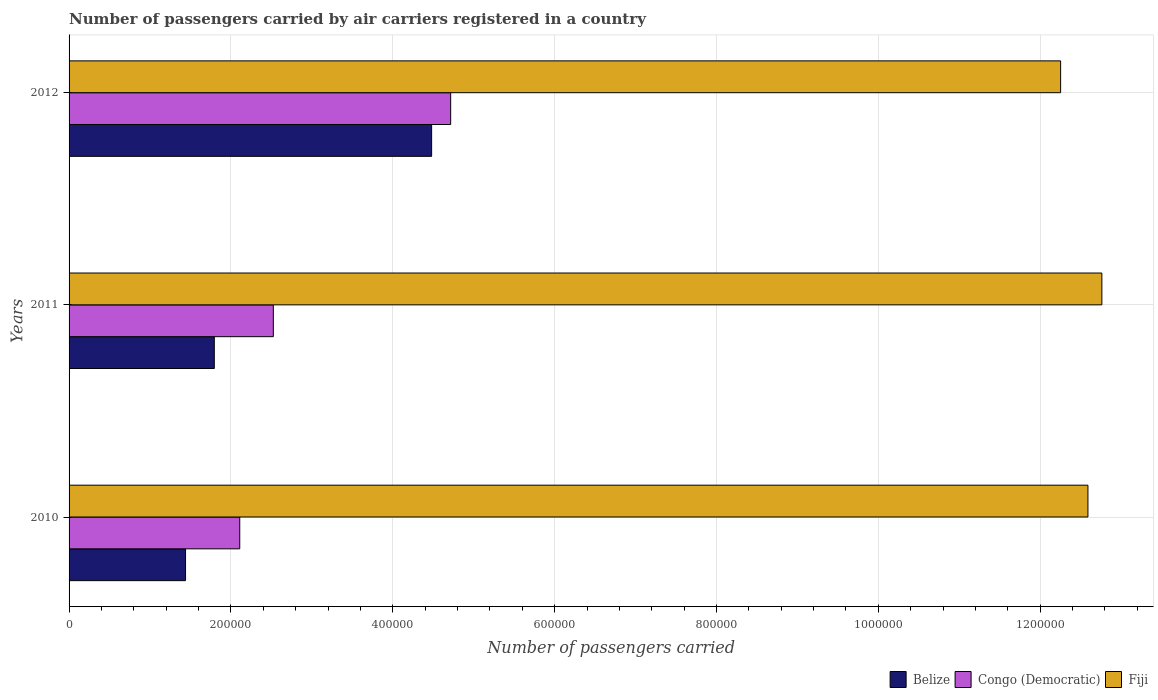How many different coloured bars are there?
Ensure brevity in your answer.  3. How many bars are there on the 3rd tick from the bottom?
Your answer should be very brief. 3. What is the label of the 3rd group of bars from the top?
Provide a short and direct response. 2010. In how many cases, is the number of bars for a given year not equal to the number of legend labels?
Your response must be concise. 0. What is the number of passengers carried by air carriers in Belize in 2011?
Make the answer very short. 1.79e+05. Across all years, what is the maximum number of passengers carried by air carriers in Congo (Democratic)?
Make the answer very short. 4.72e+05. Across all years, what is the minimum number of passengers carried by air carriers in Belize?
Provide a short and direct response. 1.44e+05. What is the total number of passengers carried by air carriers in Congo (Democratic) in the graph?
Provide a short and direct response. 9.35e+05. What is the difference between the number of passengers carried by air carriers in Belize in 2011 and that in 2012?
Your answer should be very brief. -2.69e+05. What is the difference between the number of passengers carried by air carriers in Belize in 2010 and the number of passengers carried by air carriers in Fiji in 2012?
Make the answer very short. -1.08e+06. What is the average number of passengers carried by air carriers in Belize per year?
Your answer should be compact. 2.57e+05. In the year 2010, what is the difference between the number of passengers carried by air carriers in Fiji and number of passengers carried by air carriers in Congo (Democratic)?
Ensure brevity in your answer.  1.05e+06. In how many years, is the number of passengers carried by air carriers in Congo (Democratic) greater than 720000 ?
Ensure brevity in your answer.  0. What is the ratio of the number of passengers carried by air carriers in Fiji in 2010 to that in 2012?
Make the answer very short. 1.03. Is the number of passengers carried by air carriers in Fiji in 2011 less than that in 2012?
Your response must be concise. No. What is the difference between the highest and the second highest number of passengers carried by air carriers in Congo (Democratic)?
Your answer should be very brief. 2.19e+05. What is the difference between the highest and the lowest number of passengers carried by air carriers in Congo (Democratic)?
Your answer should be very brief. 2.61e+05. In how many years, is the number of passengers carried by air carriers in Belize greater than the average number of passengers carried by air carriers in Belize taken over all years?
Your response must be concise. 1. Is the sum of the number of passengers carried by air carriers in Congo (Democratic) in 2011 and 2012 greater than the maximum number of passengers carried by air carriers in Fiji across all years?
Your response must be concise. No. What does the 2nd bar from the top in 2011 represents?
Your response must be concise. Congo (Democratic). What does the 2nd bar from the bottom in 2011 represents?
Keep it short and to the point. Congo (Democratic). Is it the case that in every year, the sum of the number of passengers carried by air carriers in Belize and number of passengers carried by air carriers in Congo (Democratic) is greater than the number of passengers carried by air carriers in Fiji?
Your response must be concise. No. How many years are there in the graph?
Offer a very short reply. 3. Are the values on the major ticks of X-axis written in scientific E-notation?
Your answer should be very brief. No. Does the graph contain grids?
Keep it short and to the point. Yes. How many legend labels are there?
Your response must be concise. 3. How are the legend labels stacked?
Ensure brevity in your answer.  Horizontal. What is the title of the graph?
Offer a terse response. Number of passengers carried by air carriers registered in a country. Does "Spain" appear as one of the legend labels in the graph?
Ensure brevity in your answer.  No. What is the label or title of the X-axis?
Your answer should be very brief. Number of passengers carried. What is the label or title of the Y-axis?
Your answer should be very brief. Years. What is the Number of passengers carried in Belize in 2010?
Offer a very short reply. 1.44e+05. What is the Number of passengers carried in Congo (Democratic) in 2010?
Your answer should be very brief. 2.11e+05. What is the Number of passengers carried of Fiji in 2010?
Offer a very short reply. 1.26e+06. What is the Number of passengers carried of Belize in 2011?
Offer a very short reply. 1.79e+05. What is the Number of passengers carried in Congo (Democratic) in 2011?
Provide a succinct answer. 2.52e+05. What is the Number of passengers carried of Fiji in 2011?
Offer a very short reply. 1.28e+06. What is the Number of passengers carried in Belize in 2012?
Your answer should be very brief. 4.48e+05. What is the Number of passengers carried of Congo (Democratic) in 2012?
Keep it short and to the point. 4.72e+05. What is the Number of passengers carried of Fiji in 2012?
Your response must be concise. 1.23e+06. Across all years, what is the maximum Number of passengers carried of Belize?
Make the answer very short. 4.48e+05. Across all years, what is the maximum Number of passengers carried of Congo (Democratic)?
Offer a terse response. 4.72e+05. Across all years, what is the maximum Number of passengers carried of Fiji?
Give a very brief answer. 1.28e+06. Across all years, what is the minimum Number of passengers carried of Belize?
Offer a terse response. 1.44e+05. Across all years, what is the minimum Number of passengers carried of Congo (Democratic)?
Your answer should be very brief. 2.11e+05. Across all years, what is the minimum Number of passengers carried of Fiji?
Give a very brief answer. 1.23e+06. What is the total Number of passengers carried of Belize in the graph?
Provide a short and direct response. 7.71e+05. What is the total Number of passengers carried in Congo (Democratic) in the graph?
Your answer should be very brief. 9.35e+05. What is the total Number of passengers carried in Fiji in the graph?
Your response must be concise. 3.76e+06. What is the difference between the Number of passengers carried in Belize in 2010 and that in 2011?
Keep it short and to the point. -3.55e+04. What is the difference between the Number of passengers carried of Congo (Democratic) in 2010 and that in 2011?
Your answer should be compact. -4.15e+04. What is the difference between the Number of passengers carried in Fiji in 2010 and that in 2011?
Provide a short and direct response. -1.72e+04. What is the difference between the Number of passengers carried in Belize in 2010 and that in 2012?
Offer a terse response. -3.04e+05. What is the difference between the Number of passengers carried of Congo (Democratic) in 2010 and that in 2012?
Your answer should be compact. -2.61e+05. What is the difference between the Number of passengers carried in Fiji in 2010 and that in 2012?
Offer a terse response. 3.37e+04. What is the difference between the Number of passengers carried in Belize in 2011 and that in 2012?
Your response must be concise. -2.69e+05. What is the difference between the Number of passengers carried of Congo (Democratic) in 2011 and that in 2012?
Provide a short and direct response. -2.19e+05. What is the difference between the Number of passengers carried of Fiji in 2011 and that in 2012?
Keep it short and to the point. 5.09e+04. What is the difference between the Number of passengers carried in Belize in 2010 and the Number of passengers carried in Congo (Democratic) in 2011?
Keep it short and to the point. -1.08e+05. What is the difference between the Number of passengers carried in Belize in 2010 and the Number of passengers carried in Fiji in 2011?
Give a very brief answer. -1.13e+06. What is the difference between the Number of passengers carried in Congo (Democratic) in 2010 and the Number of passengers carried in Fiji in 2011?
Ensure brevity in your answer.  -1.07e+06. What is the difference between the Number of passengers carried in Belize in 2010 and the Number of passengers carried in Congo (Democratic) in 2012?
Your answer should be compact. -3.28e+05. What is the difference between the Number of passengers carried of Belize in 2010 and the Number of passengers carried of Fiji in 2012?
Offer a very short reply. -1.08e+06. What is the difference between the Number of passengers carried in Congo (Democratic) in 2010 and the Number of passengers carried in Fiji in 2012?
Give a very brief answer. -1.01e+06. What is the difference between the Number of passengers carried of Belize in 2011 and the Number of passengers carried of Congo (Democratic) in 2012?
Offer a terse response. -2.92e+05. What is the difference between the Number of passengers carried of Belize in 2011 and the Number of passengers carried of Fiji in 2012?
Provide a succinct answer. -1.05e+06. What is the difference between the Number of passengers carried of Congo (Democratic) in 2011 and the Number of passengers carried of Fiji in 2012?
Provide a short and direct response. -9.73e+05. What is the average Number of passengers carried of Belize per year?
Offer a very short reply. 2.57e+05. What is the average Number of passengers carried of Congo (Democratic) per year?
Provide a short and direct response. 3.12e+05. What is the average Number of passengers carried of Fiji per year?
Provide a succinct answer. 1.25e+06. In the year 2010, what is the difference between the Number of passengers carried of Belize and Number of passengers carried of Congo (Democratic)?
Provide a succinct answer. -6.70e+04. In the year 2010, what is the difference between the Number of passengers carried of Belize and Number of passengers carried of Fiji?
Your response must be concise. -1.12e+06. In the year 2010, what is the difference between the Number of passengers carried of Congo (Democratic) and Number of passengers carried of Fiji?
Keep it short and to the point. -1.05e+06. In the year 2011, what is the difference between the Number of passengers carried in Belize and Number of passengers carried in Congo (Democratic)?
Your response must be concise. -7.29e+04. In the year 2011, what is the difference between the Number of passengers carried of Belize and Number of passengers carried of Fiji?
Your answer should be very brief. -1.10e+06. In the year 2011, what is the difference between the Number of passengers carried of Congo (Democratic) and Number of passengers carried of Fiji?
Offer a very short reply. -1.02e+06. In the year 2012, what is the difference between the Number of passengers carried in Belize and Number of passengers carried in Congo (Democratic)?
Your answer should be compact. -2.35e+04. In the year 2012, what is the difference between the Number of passengers carried in Belize and Number of passengers carried in Fiji?
Make the answer very short. -7.77e+05. In the year 2012, what is the difference between the Number of passengers carried in Congo (Democratic) and Number of passengers carried in Fiji?
Offer a terse response. -7.54e+05. What is the ratio of the Number of passengers carried of Belize in 2010 to that in 2011?
Keep it short and to the point. 0.8. What is the ratio of the Number of passengers carried of Congo (Democratic) in 2010 to that in 2011?
Give a very brief answer. 0.84. What is the ratio of the Number of passengers carried of Fiji in 2010 to that in 2011?
Your answer should be compact. 0.99. What is the ratio of the Number of passengers carried in Belize in 2010 to that in 2012?
Your answer should be very brief. 0.32. What is the ratio of the Number of passengers carried in Congo (Democratic) in 2010 to that in 2012?
Give a very brief answer. 0.45. What is the ratio of the Number of passengers carried in Fiji in 2010 to that in 2012?
Ensure brevity in your answer.  1.03. What is the ratio of the Number of passengers carried of Belize in 2011 to that in 2012?
Keep it short and to the point. 0.4. What is the ratio of the Number of passengers carried of Congo (Democratic) in 2011 to that in 2012?
Your response must be concise. 0.54. What is the ratio of the Number of passengers carried in Fiji in 2011 to that in 2012?
Ensure brevity in your answer.  1.04. What is the difference between the highest and the second highest Number of passengers carried of Belize?
Offer a very short reply. 2.69e+05. What is the difference between the highest and the second highest Number of passengers carried of Congo (Democratic)?
Offer a very short reply. 2.19e+05. What is the difference between the highest and the second highest Number of passengers carried in Fiji?
Offer a terse response. 1.72e+04. What is the difference between the highest and the lowest Number of passengers carried of Belize?
Keep it short and to the point. 3.04e+05. What is the difference between the highest and the lowest Number of passengers carried of Congo (Democratic)?
Offer a terse response. 2.61e+05. What is the difference between the highest and the lowest Number of passengers carried of Fiji?
Make the answer very short. 5.09e+04. 